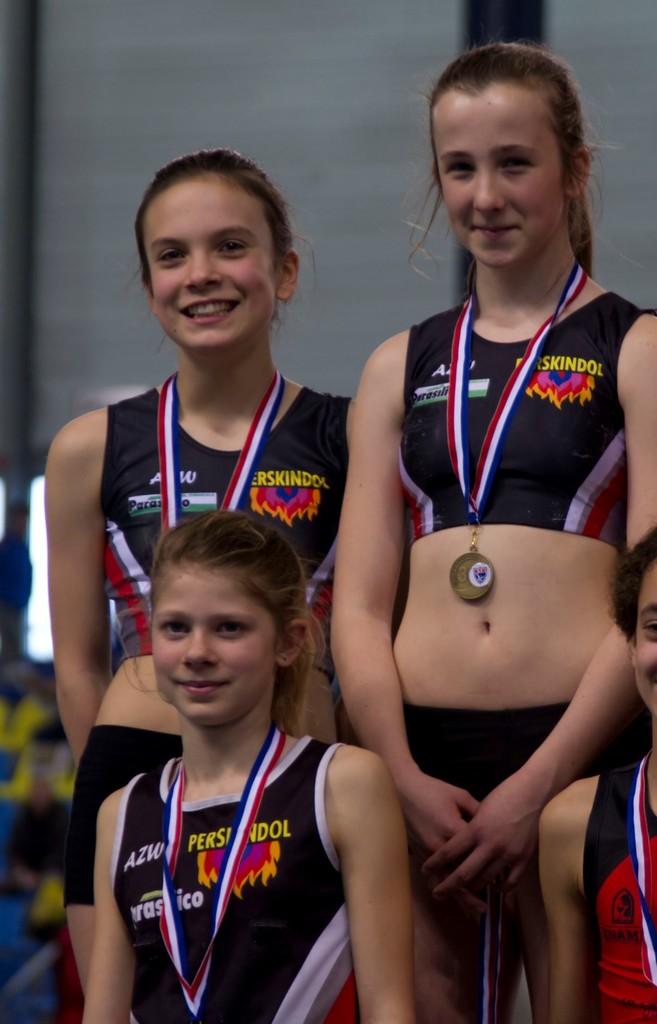What team do they represent?
Your answer should be compact. Perskindol. 